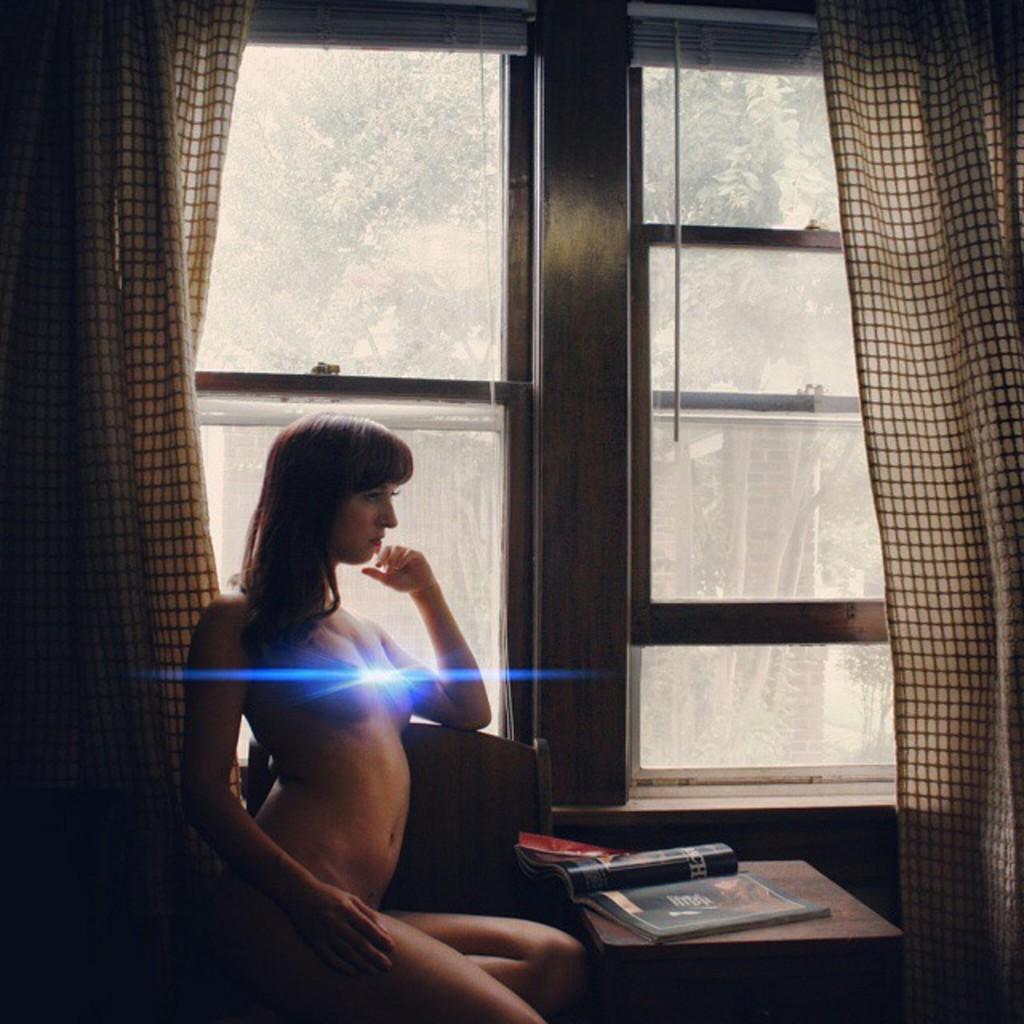Can you describe this image briefly? In the picture a woman is sitting on a chair near the window on the table there are some books there is a curtain near the window through the glass window we can say trees. 